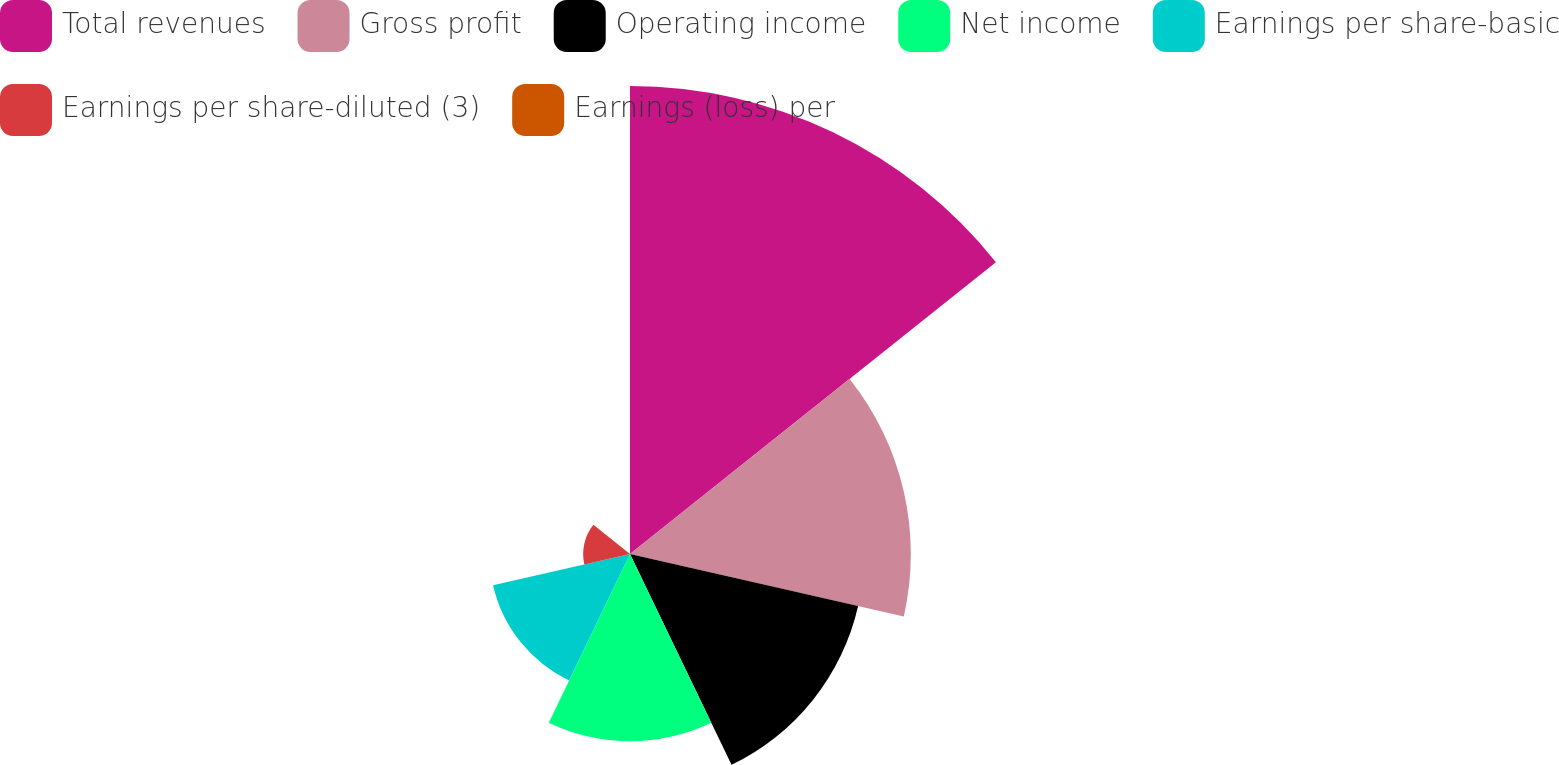Convert chart to OTSL. <chart><loc_0><loc_0><loc_500><loc_500><pie_chart><fcel>Total revenues<fcel>Gross profit<fcel>Operating income<fcel>Net income<fcel>Earnings per share-basic<fcel>Earnings per share-diluted (3)<fcel>Earnings (loss) per<nl><fcel>34.48%<fcel>20.69%<fcel>17.24%<fcel>13.79%<fcel>10.35%<fcel>3.45%<fcel>0.01%<nl></chart> 